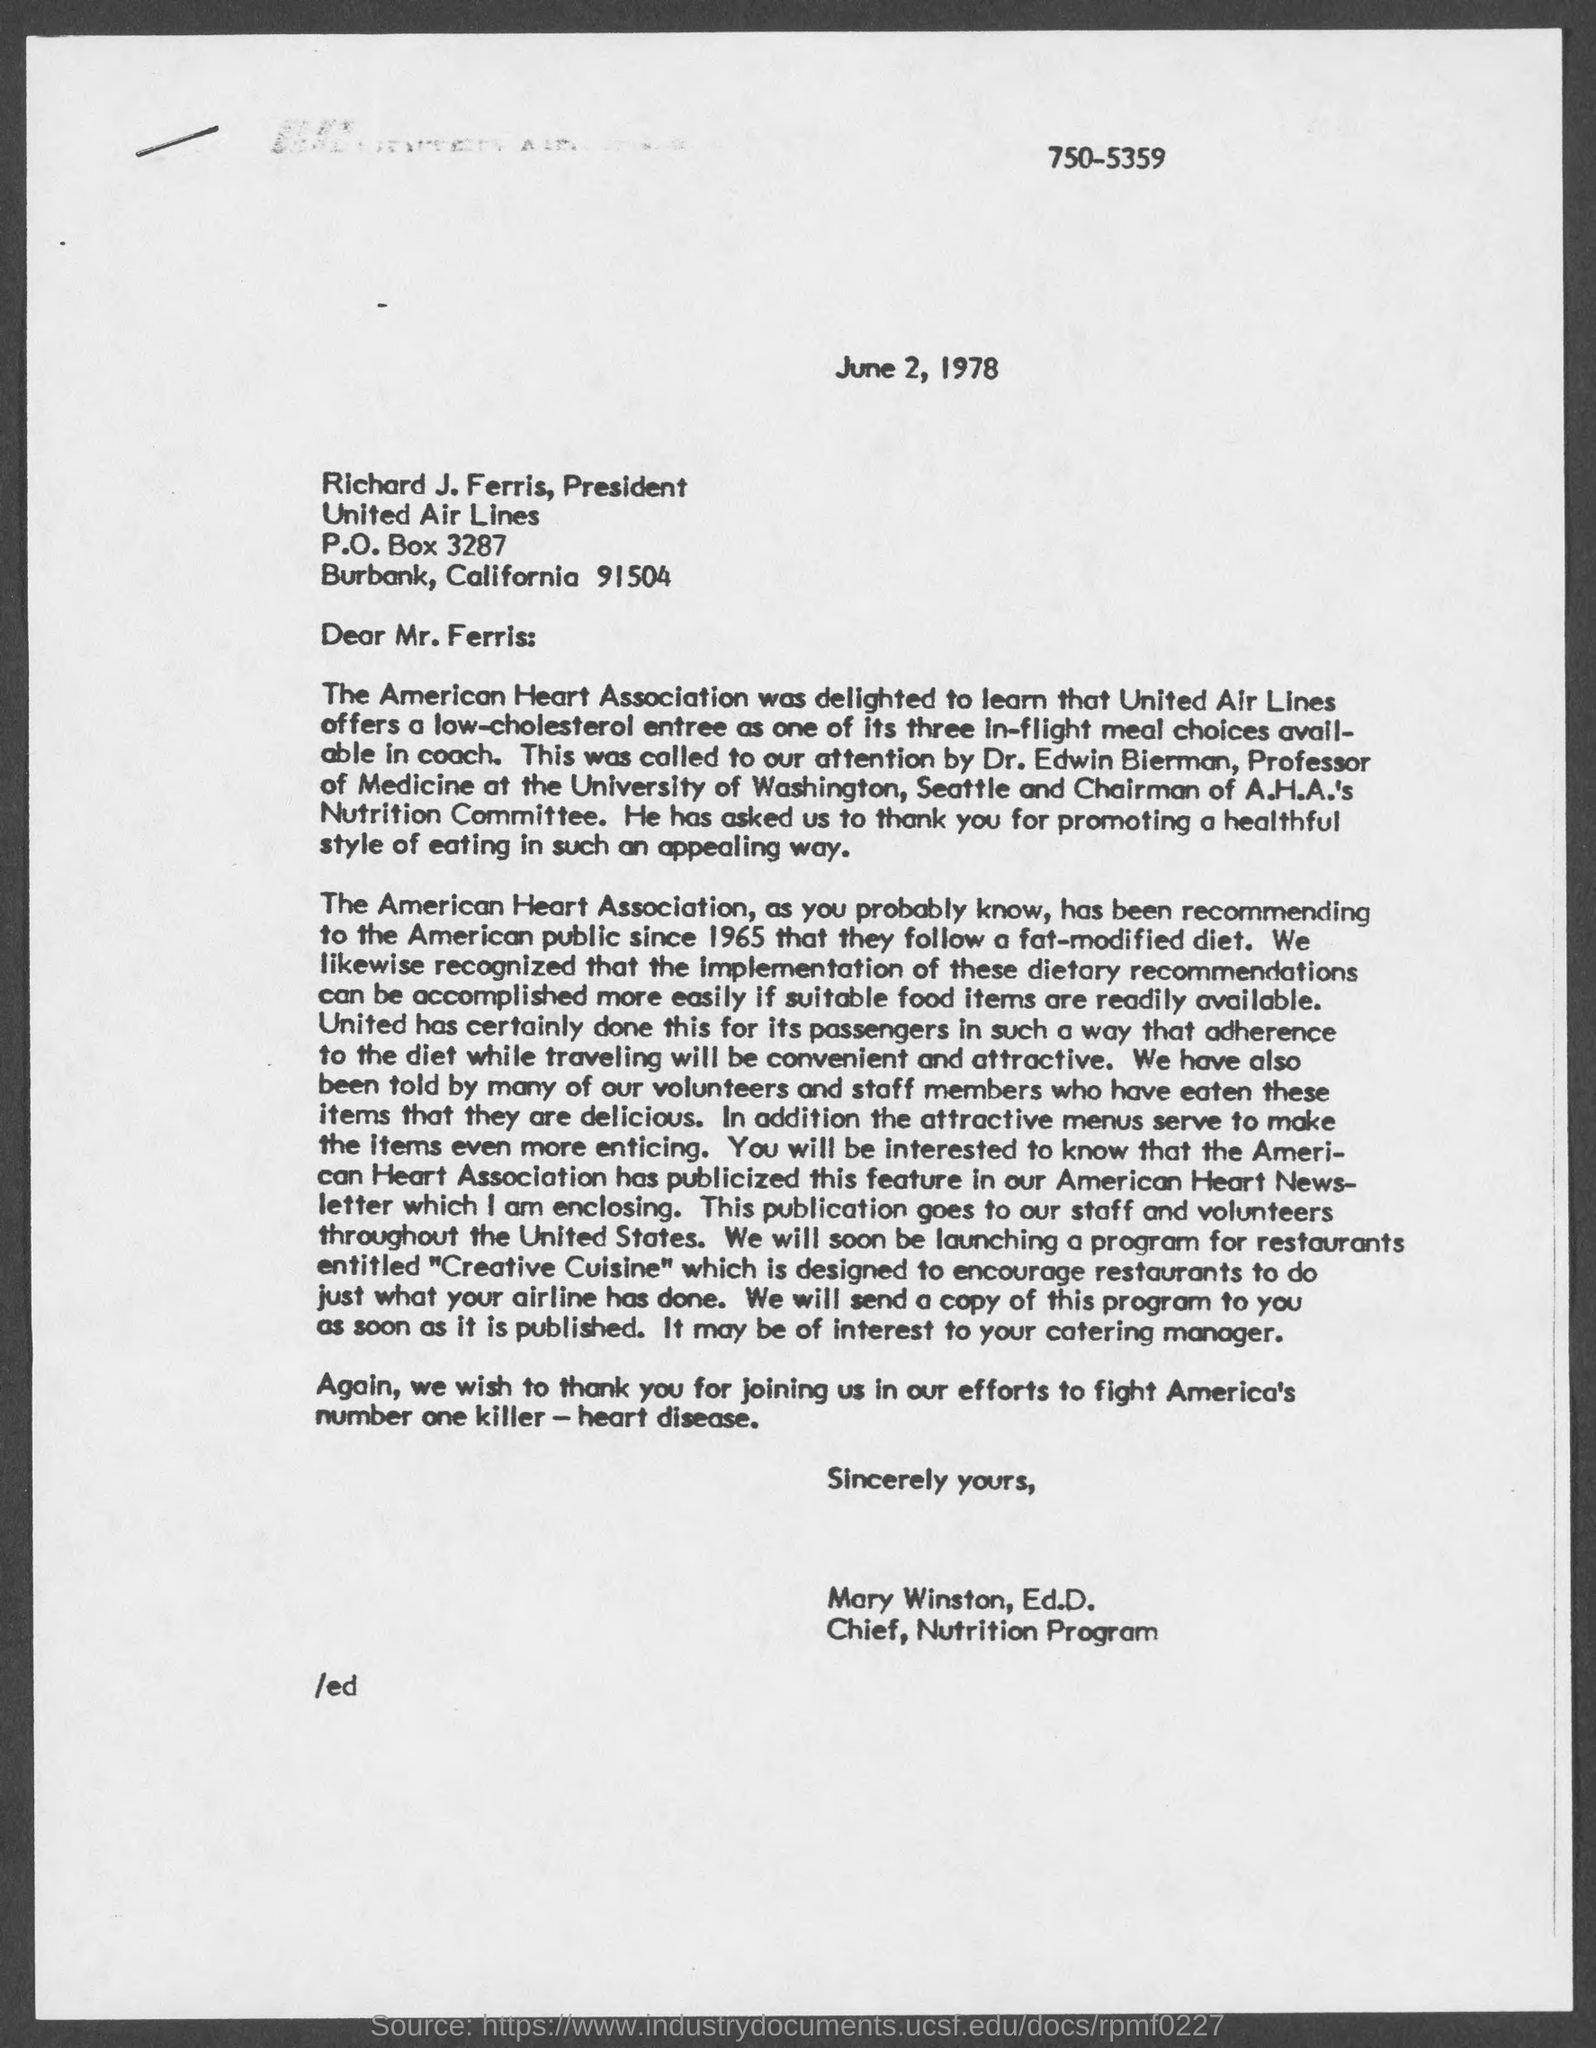What is the date mentioned in this letter?
Ensure brevity in your answer.  June 2, 1978. Who is the Chairman of A.H.A.'s Nutrition Committee?
Your response must be concise. Dr. Edwin Bierman. 